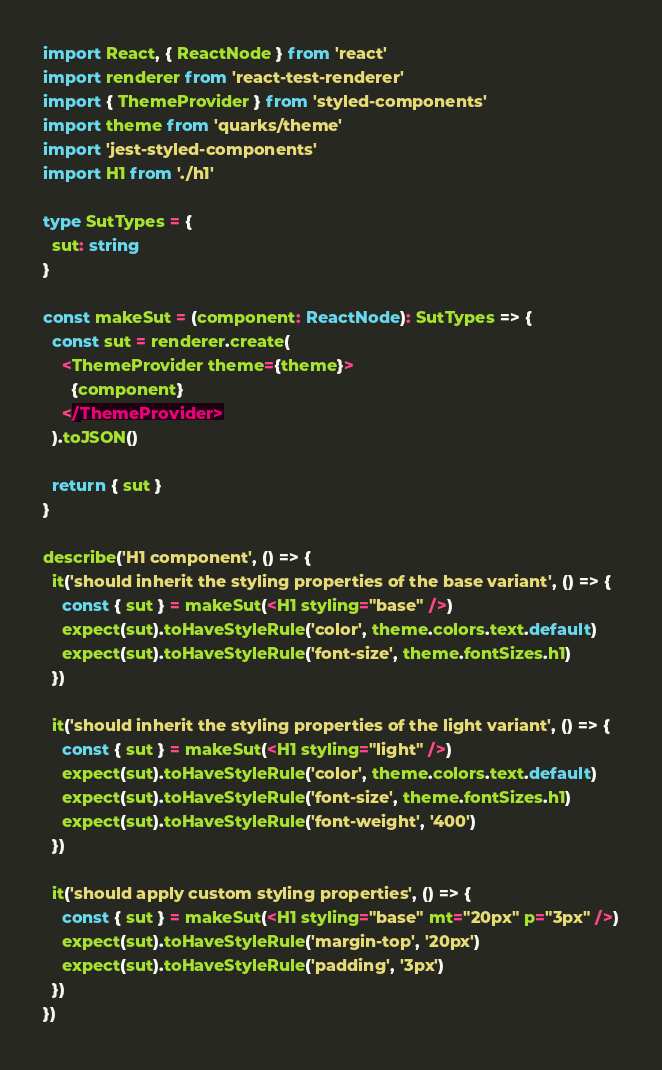<code> <loc_0><loc_0><loc_500><loc_500><_TypeScript_>import React, { ReactNode } from 'react'
import renderer from 'react-test-renderer'
import { ThemeProvider } from 'styled-components'
import theme from 'quarks/theme'
import 'jest-styled-components'
import H1 from './h1'

type SutTypes = {
  sut: string
}

const makeSut = (component: ReactNode): SutTypes => {
  const sut = renderer.create(
    <ThemeProvider theme={theme}>
      {component}
    </ThemeProvider>
  ).toJSON()

  return { sut }
}

describe('H1 component', () => {
  it('should inherit the styling properties of the base variant', () => {
    const { sut } = makeSut(<H1 styling="base" />)
    expect(sut).toHaveStyleRule('color', theme.colors.text.default)
    expect(sut).toHaveStyleRule('font-size', theme.fontSizes.h1)
  })

  it('should inherit the styling properties of the light variant', () => {
    const { sut } = makeSut(<H1 styling="light" />)
    expect(sut).toHaveStyleRule('color', theme.colors.text.default)
    expect(sut).toHaveStyleRule('font-size', theme.fontSizes.h1)
    expect(sut).toHaveStyleRule('font-weight', '400')
  })

  it('should apply custom styling properties', () => {
    const { sut } = makeSut(<H1 styling="base" mt="20px" p="3px" />)
    expect(sut).toHaveStyleRule('margin-top', '20px')
    expect(sut).toHaveStyleRule('padding', '3px')
  })
})
</code> 